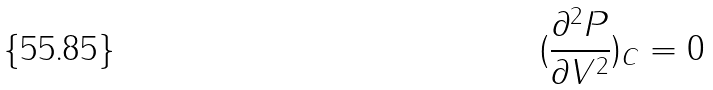Convert formula to latex. <formula><loc_0><loc_0><loc_500><loc_500>( \frac { \partial ^ { 2 } P } { \partial V ^ { 2 } } ) _ { C } = 0</formula> 